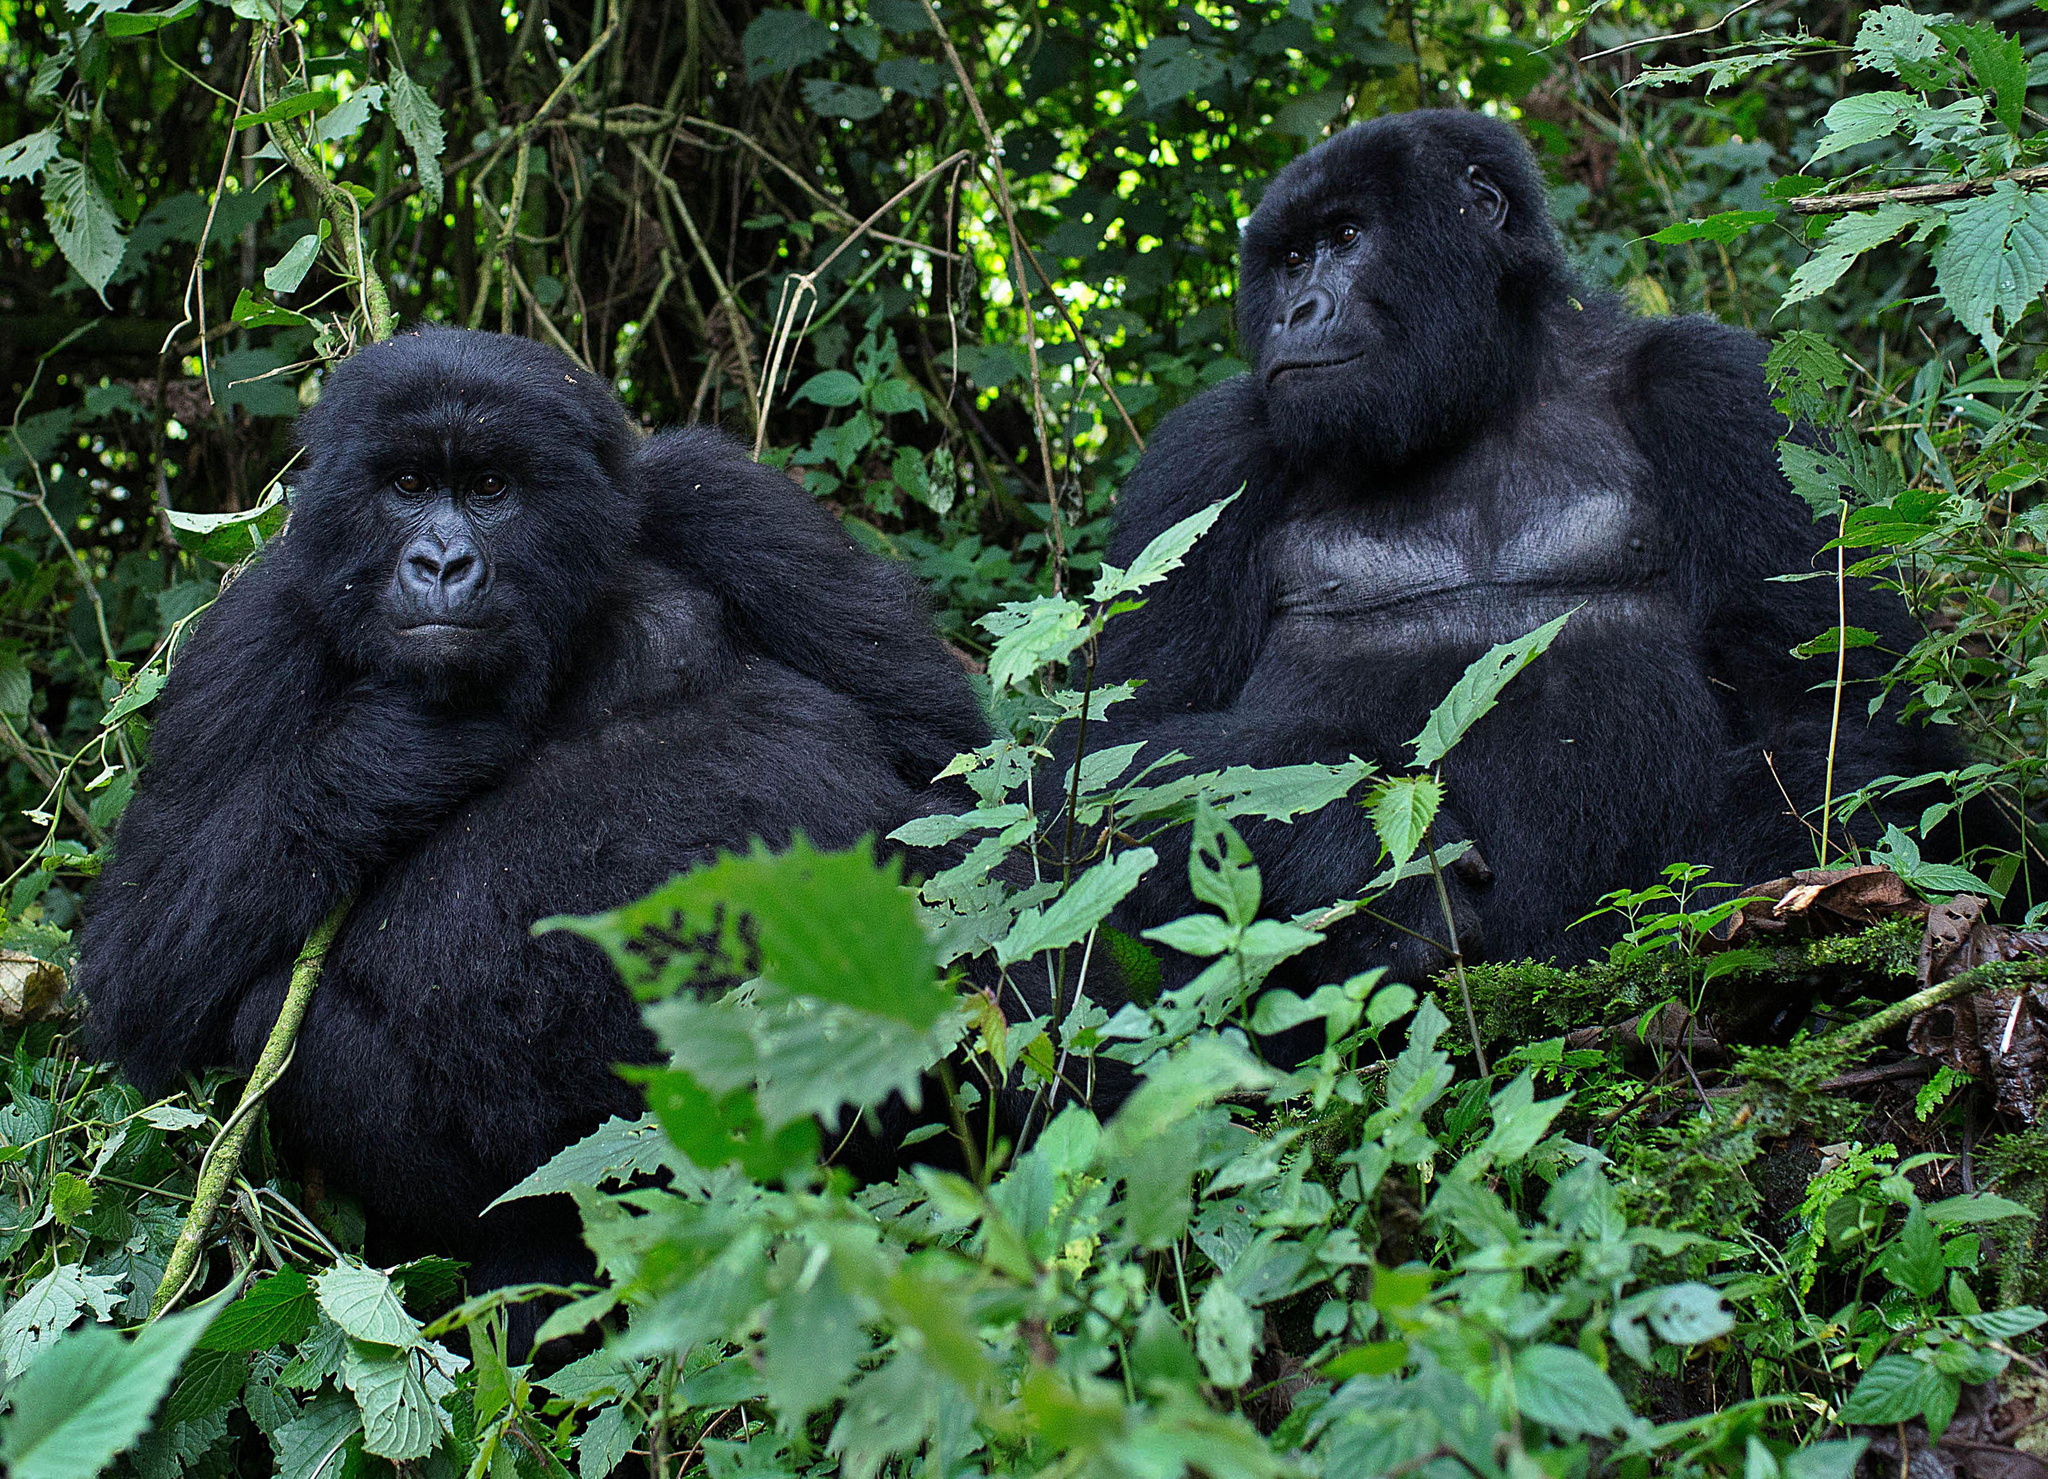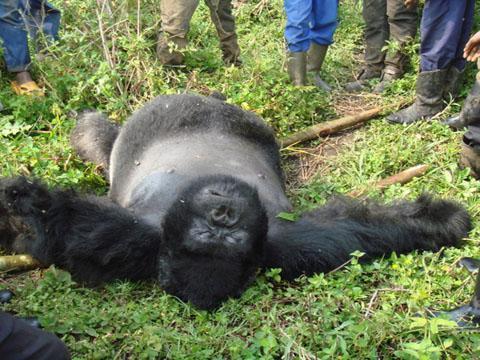The first image is the image on the left, the second image is the image on the right. Considering the images on both sides, is "One image shows a single ape lying upside-down on its back, with the top of its head facing the camera." valid? Answer yes or no. Yes. The first image is the image on the left, the second image is the image on the right. Considering the images on both sides, is "The right image contains exactly one gorilla laying on its back surrounded by green foliage." valid? Answer yes or no. Yes. 